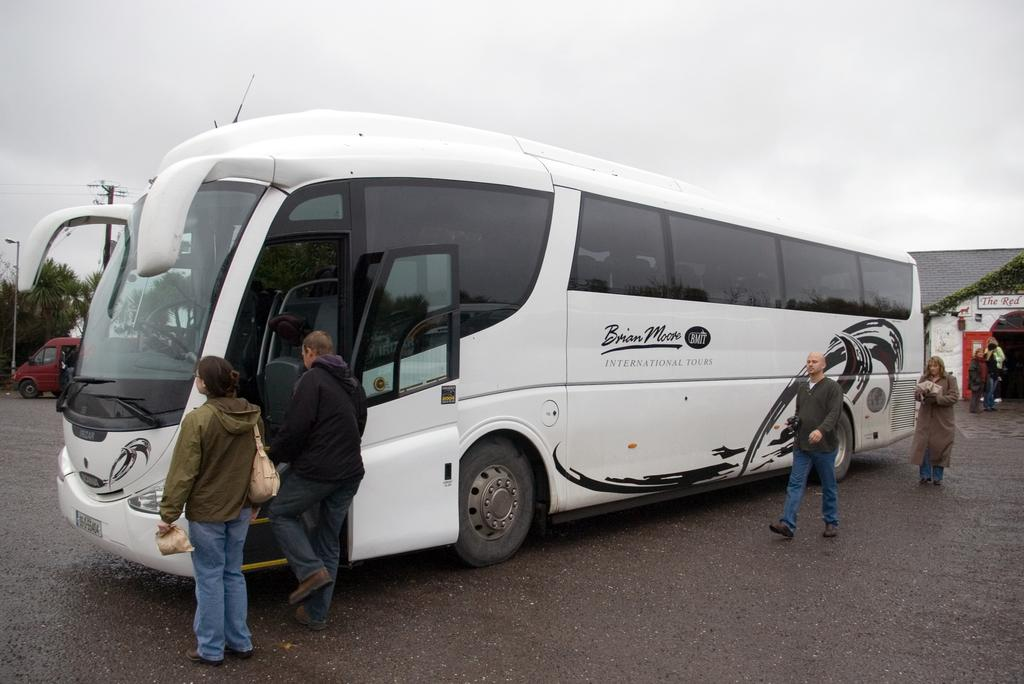What types of objects can be seen in the image? There are vehicles, trees, people, wires, poles, a house, and text on the house visible in the image. Can you describe the natural elements in the image? There are trees in the image. What type of structure is present in the image? There is a house in the image. What is written on the house? There is text on the house. What is visible in the background of the image? The sky is visible in the background of the image. Is there a lake visible in the image? There is no lake present in the image. Can you describe the type of bath that is being taken in the image? There is no bath or any indication of bathing in the image. 